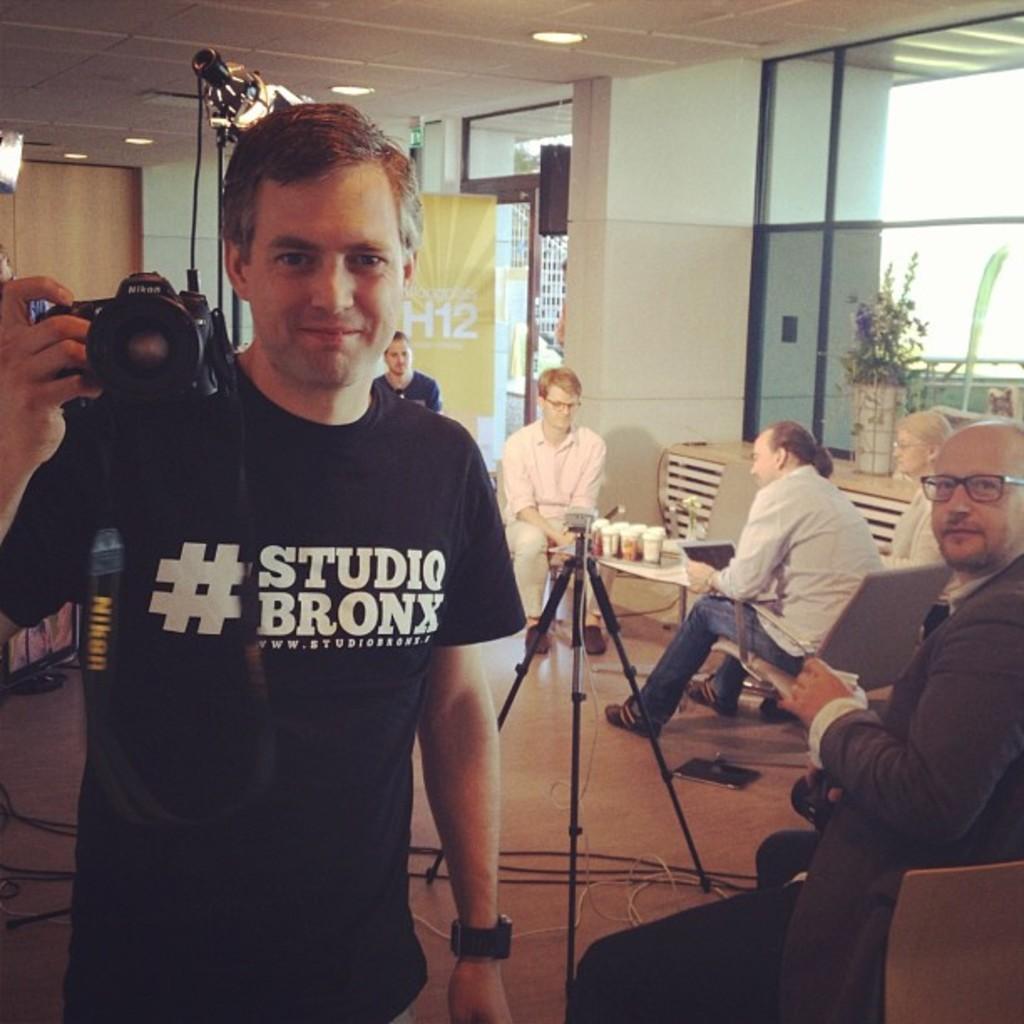Please provide a concise description of this image. As we can see in the image there are tiles, window, wall, few people sitting on chairs and table. On table there are glasses. The man who is standing here is holding camera. 